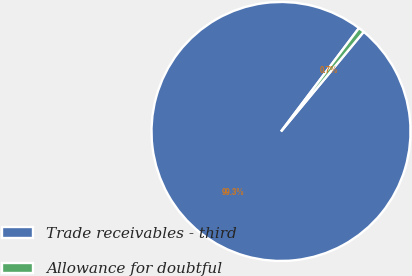Convert chart. <chart><loc_0><loc_0><loc_500><loc_500><pie_chart><fcel>Trade receivables - third<fcel>Allowance for doubtful<nl><fcel>99.26%<fcel>0.74%<nl></chart> 